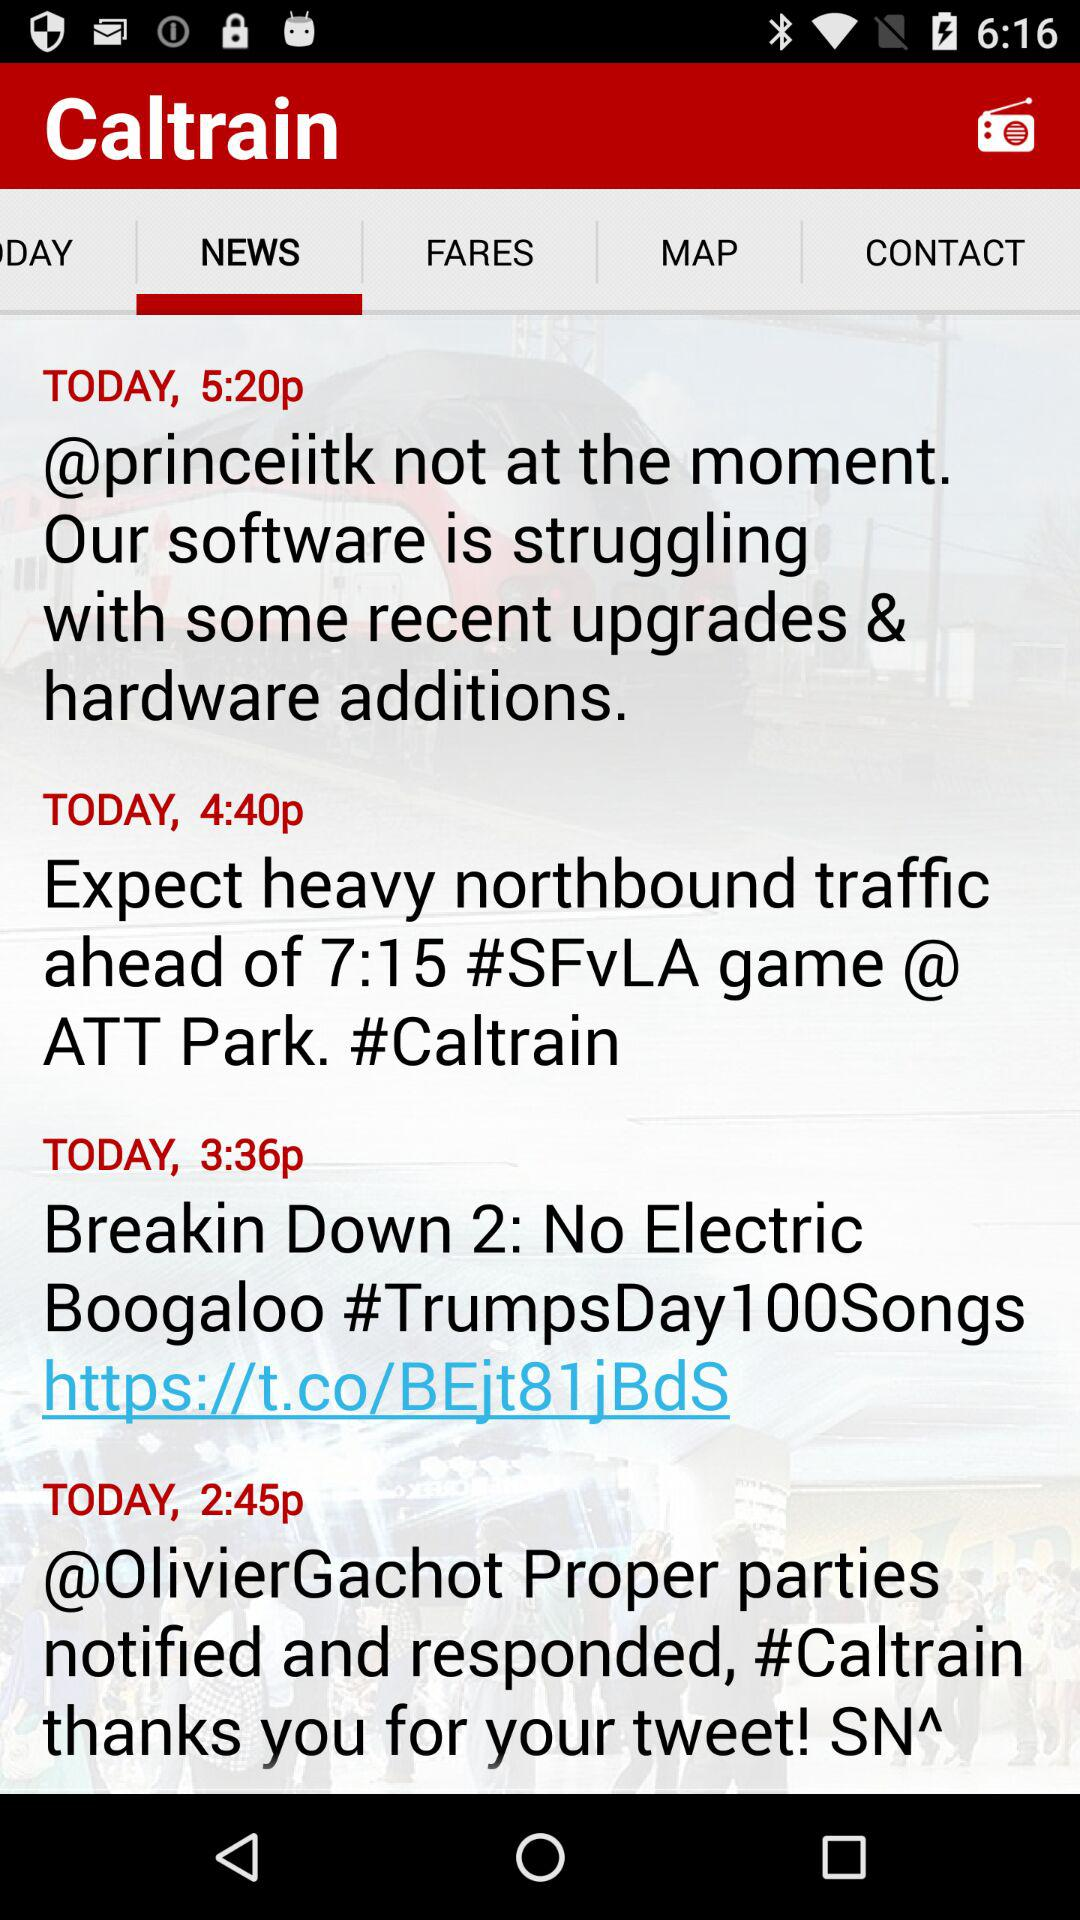What is the selected library?
When the provided information is insufficient, respond with <no answer>. <no answer> 